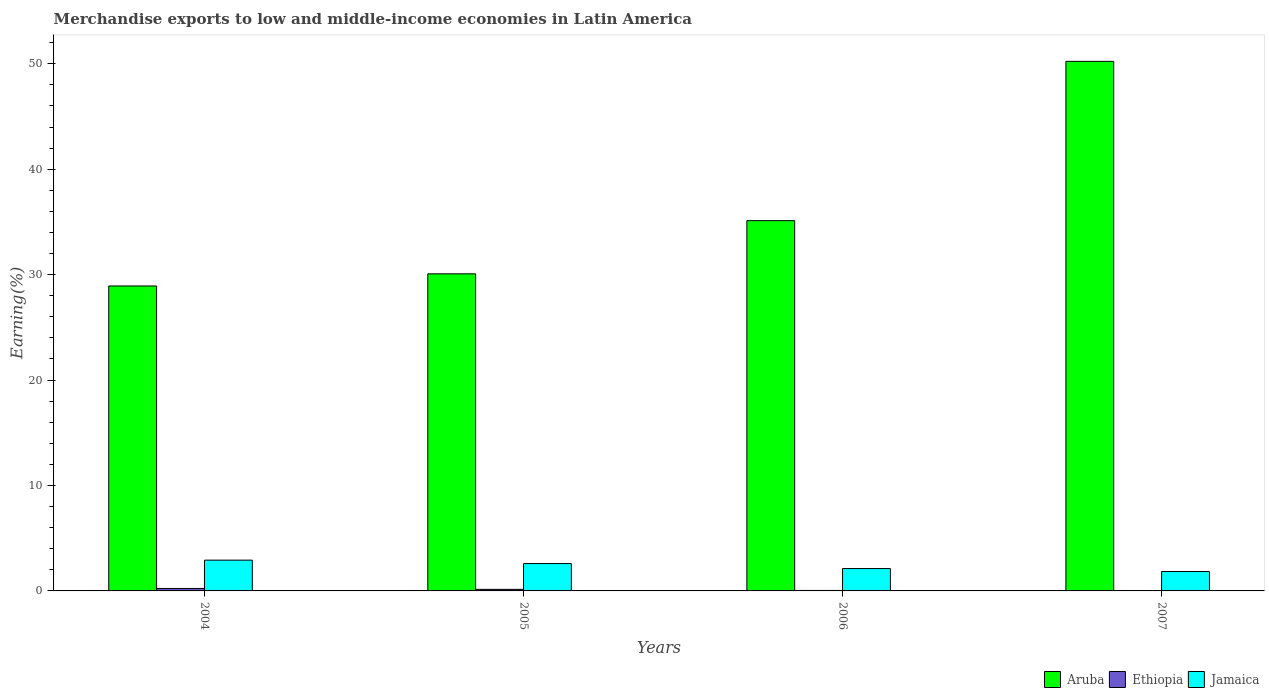Are the number of bars per tick equal to the number of legend labels?
Keep it short and to the point. Yes. What is the label of the 3rd group of bars from the left?
Your answer should be very brief. 2006. What is the percentage of amount earned from merchandise exports in Ethiopia in 2005?
Your answer should be compact. 0.15. Across all years, what is the maximum percentage of amount earned from merchandise exports in Ethiopia?
Ensure brevity in your answer.  0.23. Across all years, what is the minimum percentage of amount earned from merchandise exports in Aruba?
Give a very brief answer. 28.93. In which year was the percentage of amount earned from merchandise exports in Aruba maximum?
Make the answer very short. 2007. In which year was the percentage of amount earned from merchandise exports in Jamaica minimum?
Keep it short and to the point. 2007. What is the total percentage of amount earned from merchandise exports in Aruba in the graph?
Provide a short and direct response. 144.37. What is the difference between the percentage of amount earned from merchandise exports in Jamaica in 2006 and that in 2007?
Your response must be concise. 0.28. What is the difference between the percentage of amount earned from merchandise exports in Ethiopia in 2007 and the percentage of amount earned from merchandise exports in Jamaica in 2005?
Your response must be concise. -2.57. What is the average percentage of amount earned from merchandise exports in Aruba per year?
Offer a terse response. 36.09. In the year 2004, what is the difference between the percentage of amount earned from merchandise exports in Jamaica and percentage of amount earned from merchandise exports in Aruba?
Your response must be concise. -26.01. What is the ratio of the percentage of amount earned from merchandise exports in Ethiopia in 2004 to that in 2005?
Your answer should be compact. 1.56. Is the difference between the percentage of amount earned from merchandise exports in Jamaica in 2006 and 2007 greater than the difference between the percentage of amount earned from merchandise exports in Aruba in 2006 and 2007?
Your answer should be compact. Yes. What is the difference between the highest and the second highest percentage of amount earned from merchandise exports in Jamaica?
Provide a short and direct response. 0.32. What is the difference between the highest and the lowest percentage of amount earned from merchandise exports in Ethiopia?
Keep it short and to the point. 0.21. Is the sum of the percentage of amount earned from merchandise exports in Ethiopia in 2004 and 2007 greater than the maximum percentage of amount earned from merchandise exports in Jamaica across all years?
Give a very brief answer. No. What does the 3rd bar from the left in 2004 represents?
Ensure brevity in your answer.  Jamaica. What does the 3rd bar from the right in 2005 represents?
Ensure brevity in your answer.  Aruba. How many bars are there?
Your answer should be very brief. 12. Are all the bars in the graph horizontal?
Provide a succinct answer. No. What is the difference between two consecutive major ticks on the Y-axis?
Offer a very short reply. 10. Are the values on the major ticks of Y-axis written in scientific E-notation?
Ensure brevity in your answer.  No. Does the graph contain any zero values?
Give a very brief answer. No. Does the graph contain grids?
Offer a terse response. No. How are the legend labels stacked?
Give a very brief answer. Horizontal. What is the title of the graph?
Give a very brief answer. Merchandise exports to low and middle-income economies in Latin America. Does "Norway" appear as one of the legend labels in the graph?
Provide a short and direct response. No. What is the label or title of the Y-axis?
Provide a succinct answer. Earning(%). What is the Earning(%) of Aruba in 2004?
Keep it short and to the point. 28.93. What is the Earning(%) in Ethiopia in 2004?
Your response must be concise. 0.23. What is the Earning(%) of Jamaica in 2004?
Keep it short and to the point. 2.92. What is the Earning(%) in Aruba in 2005?
Ensure brevity in your answer.  30.08. What is the Earning(%) of Ethiopia in 2005?
Provide a short and direct response. 0.15. What is the Earning(%) of Jamaica in 2005?
Your answer should be compact. 2.6. What is the Earning(%) in Aruba in 2006?
Keep it short and to the point. 35.12. What is the Earning(%) in Ethiopia in 2006?
Keep it short and to the point. 0.05. What is the Earning(%) of Jamaica in 2006?
Offer a very short reply. 2.12. What is the Earning(%) in Aruba in 2007?
Your answer should be very brief. 50.23. What is the Earning(%) of Ethiopia in 2007?
Your answer should be compact. 0.02. What is the Earning(%) of Jamaica in 2007?
Keep it short and to the point. 1.84. Across all years, what is the maximum Earning(%) of Aruba?
Make the answer very short. 50.23. Across all years, what is the maximum Earning(%) in Ethiopia?
Offer a very short reply. 0.23. Across all years, what is the maximum Earning(%) of Jamaica?
Your response must be concise. 2.92. Across all years, what is the minimum Earning(%) in Aruba?
Make the answer very short. 28.93. Across all years, what is the minimum Earning(%) in Ethiopia?
Your answer should be compact. 0.02. Across all years, what is the minimum Earning(%) of Jamaica?
Your answer should be very brief. 1.84. What is the total Earning(%) of Aruba in the graph?
Keep it short and to the point. 144.37. What is the total Earning(%) of Ethiopia in the graph?
Your answer should be compact. 0.45. What is the total Earning(%) of Jamaica in the graph?
Ensure brevity in your answer.  9.48. What is the difference between the Earning(%) of Aruba in 2004 and that in 2005?
Your response must be concise. -1.15. What is the difference between the Earning(%) in Ethiopia in 2004 and that in 2005?
Give a very brief answer. 0.08. What is the difference between the Earning(%) in Jamaica in 2004 and that in 2005?
Provide a succinct answer. 0.32. What is the difference between the Earning(%) of Aruba in 2004 and that in 2006?
Your response must be concise. -6.2. What is the difference between the Earning(%) in Ethiopia in 2004 and that in 2006?
Your response must be concise. 0.19. What is the difference between the Earning(%) in Jamaica in 2004 and that in 2006?
Your answer should be very brief. 0.8. What is the difference between the Earning(%) of Aruba in 2004 and that in 2007?
Your answer should be compact. -21.31. What is the difference between the Earning(%) in Ethiopia in 2004 and that in 2007?
Your answer should be very brief. 0.21. What is the difference between the Earning(%) of Jamaica in 2004 and that in 2007?
Provide a succinct answer. 1.08. What is the difference between the Earning(%) of Aruba in 2005 and that in 2006?
Provide a succinct answer. -5.05. What is the difference between the Earning(%) in Ethiopia in 2005 and that in 2006?
Make the answer very short. 0.1. What is the difference between the Earning(%) of Jamaica in 2005 and that in 2006?
Make the answer very short. 0.47. What is the difference between the Earning(%) of Aruba in 2005 and that in 2007?
Your response must be concise. -20.16. What is the difference between the Earning(%) in Ethiopia in 2005 and that in 2007?
Make the answer very short. 0.13. What is the difference between the Earning(%) in Jamaica in 2005 and that in 2007?
Give a very brief answer. 0.75. What is the difference between the Earning(%) in Aruba in 2006 and that in 2007?
Your answer should be very brief. -15.11. What is the difference between the Earning(%) in Ethiopia in 2006 and that in 2007?
Your answer should be compact. 0.02. What is the difference between the Earning(%) in Jamaica in 2006 and that in 2007?
Keep it short and to the point. 0.28. What is the difference between the Earning(%) in Aruba in 2004 and the Earning(%) in Ethiopia in 2005?
Ensure brevity in your answer.  28.78. What is the difference between the Earning(%) in Aruba in 2004 and the Earning(%) in Jamaica in 2005?
Your response must be concise. 26.33. What is the difference between the Earning(%) of Ethiopia in 2004 and the Earning(%) of Jamaica in 2005?
Your answer should be compact. -2.36. What is the difference between the Earning(%) in Aruba in 2004 and the Earning(%) in Ethiopia in 2006?
Your answer should be very brief. 28.88. What is the difference between the Earning(%) of Aruba in 2004 and the Earning(%) of Jamaica in 2006?
Your response must be concise. 26.8. What is the difference between the Earning(%) in Ethiopia in 2004 and the Earning(%) in Jamaica in 2006?
Offer a very short reply. -1.89. What is the difference between the Earning(%) in Aruba in 2004 and the Earning(%) in Ethiopia in 2007?
Give a very brief answer. 28.9. What is the difference between the Earning(%) in Aruba in 2004 and the Earning(%) in Jamaica in 2007?
Provide a short and direct response. 27.09. What is the difference between the Earning(%) in Ethiopia in 2004 and the Earning(%) in Jamaica in 2007?
Your answer should be very brief. -1.61. What is the difference between the Earning(%) of Aruba in 2005 and the Earning(%) of Ethiopia in 2006?
Provide a short and direct response. 30.03. What is the difference between the Earning(%) in Aruba in 2005 and the Earning(%) in Jamaica in 2006?
Offer a terse response. 27.96. What is the difference between the Earning(%) of Ethiopia in 2005 and the Earning(%) of Jamaica in 2006?
Your answer should be compact. -1.97. What is the difference between the Earning(%) of Aruba in 2005 and the Earning(%) of Ethiopia in 2007?
Make the answer very short. 30.06. What is the difference between the Earning(%) of Aruba in 2005 and the Earning(%) of Jamaica in 2007?
Give a very brief answer. 28.24. What is the difference between the Earning(%) of Ethiopia in 2005 and the Earning(%) of Jamaica in 2007?
Offer a very short reply. -1.69. What is the difference between the Earning(%) in Aruba in 2006 and the Earning(%) in Ethiopia in 2007?
Your response must be concise. 35.1. What is the difference between the Earning(%) of Aruba in 2006 and the Earning(%) of Jamaica in 2007?
Make the answer very short. 33.28. What is the difference between the Earning(%) in Ethiopia in 2006 and the Earning(%) in Jamaica in 2007?
Keep it short and to the point. -1.8. What is the average Earning(%) of Aruba per year?
Give a very brief answer. 36.09. What is the average Earning(%) in Ethiopia per year?
Provide a short and direct response. 0.11. What is the average Earning(%) in Jamaica per year?
Keep it short and to the point. 2.37. In the year 2004, what is the difference between the Earning(%) in Aruba and Earning(%) in Ethiopia?
Your answer should be compact. 28.69. In the year 2004, what is the difference between the Earning(%) of Aruba and Earning(%) of Jamaica?
Give a very brief answer. 26.01. In the year 2004, what is the difference between the Earning(%) in Ethiopia and Earning(%) in Jamaica?
Offer a terse response. -2.69. In the year 2005, what is the difference between the Earning(%) in Aruba and Earning(%) in Ethiopia?
Your answer should be very brief. 29.93. In the year 2005, what is the difference between the Earning(%) in Aruba and Earning(%) in Jamaica?
Ensure brevity in your answer.  27.48. In the year 2005, what is the difference between the Earning(%) of Ethiopia and Earning(%) of Jamaica?
Your answer should be compact. -2.45. In the year 2006, what is the difference between the Earning(%) of Aruba and Earning(%) of Ethiopia?
Your answer should be compact. 35.08. In the year 2006, what is the difference between the Earning(%) of Aruba and Earning(%) of Jamaica?
Make the answer very short. 33. In the year 2006, what is the difference between the Earning(%) of Ethiopia and Earning(%) of Jamaica?
Provide a short and direct response. -2.08. In the year 2007, what is the difference between the Earning(%) of Aruba and Earning(%) of Ethiopia?
Ensure brevity in your answer.  50.21. In the year 2007, what is the difference between the Earning(%) of Aruba and Earning(%) of Jamaica?
Your response must be concise. 48.39. In the year 2007, what is the difference between the Earning(%) of Ethiopia and Earning(%) of Jamaica?
Your answer should be compact. -1.82. What is the ratio of the Earning(%) in Aruba in 2004 to that in 2005?
Ensure brevity in your answer.  0.96. What is the ratio of the Earning(%) of Ethiopia in 2004 to that in 2005?
Your answer should be compact. 1.56. What is the ratio of the Earning(%) of Jamaica in 2004 to that in 2005?
Provide a succinct answer. 1.12. What is the ratio of the Earning(%) in Aruba in 2004 to that in 2006?
Ensure brevity in your answer.  0.82. What is the ratio of the Earning(%) in Ethiopia in 2004 to that in 2006?
Ensure brevity in your answer.  5.15. What is the ratio of the Earning(%) in Jamaica in 2004 to that in 2006?
Offer a very short reply. 1.38. What is the ratio of the Earning(%) in Aruba in 2004 to that in 2007?
Offer a very short reply. 0.58. What is the ratio of the Earning(%) of Ethiopia in 2004 to that in 2007?
Provide a short and direct response. 10.08. What is the ratio of the Earning(%) in Jamaica in 2004 to that in 2007?
Your response must be concise. 1.59. What is the ratio of the Earning(%) in Aruba in 2005 to that in 2006?
Provide a short and direct response. 0.86. What is the ratio of the Earning(%) in Ethiopia in 2005 to that in 2006?
Your answer should be compact. 3.3. What is the ratio of the Earning(%) of Jamaica in 2005 to that in 2006?
Make the answer very short. 1.22. What is the ratio of the Earning(%) in Aruba in 2005 to that in 2007?
Provide a short and direct response. 0.6. What is the ratio of the Earning(%) in Ethiopia in 2005 to that in 2007?
Offer a very short reply. 6.45. What is the ratio of the Earning(%) of Jamaica in 2005 to that in 2007?
Keep it short and to the point. 1.41. What is the ratio of the Earning(%) of Aruba in 2006 to that in 2007?
Your response must be concise. 0.7. What is the ratio of the Earning(%) of Ethiopia in 2006 to that in 2007?
Make the answer very short. 1.96. What is the ratio of the Earning(%) in Jamaica in 2006 to that in 2007?
Give a very brief answer. 1.15. What is the difference between the highest and the second highest Earning(%) in Aruba?
Your answer should be compact. 15.11. What is the difference between the highest and the second highest Earning(%) in Ethiopia?
Your answer should be compact. 0.08. What is the difference between the highest and the second highest Earning(%) in Jamaica?
Ensure brevity in your answer.  0.32. What is the difference between the highest and the lowest Earning(%) of Aruba?
Offer a terse response. 21.31. What is the difference between the highest and the lowest Earning(%) in Ethiopia?
Give a very brief answer. 0.21. What is the difference between the highest and the lowest Earning(%) of Jamaica?
Provide a succinct answer. 1.08. 